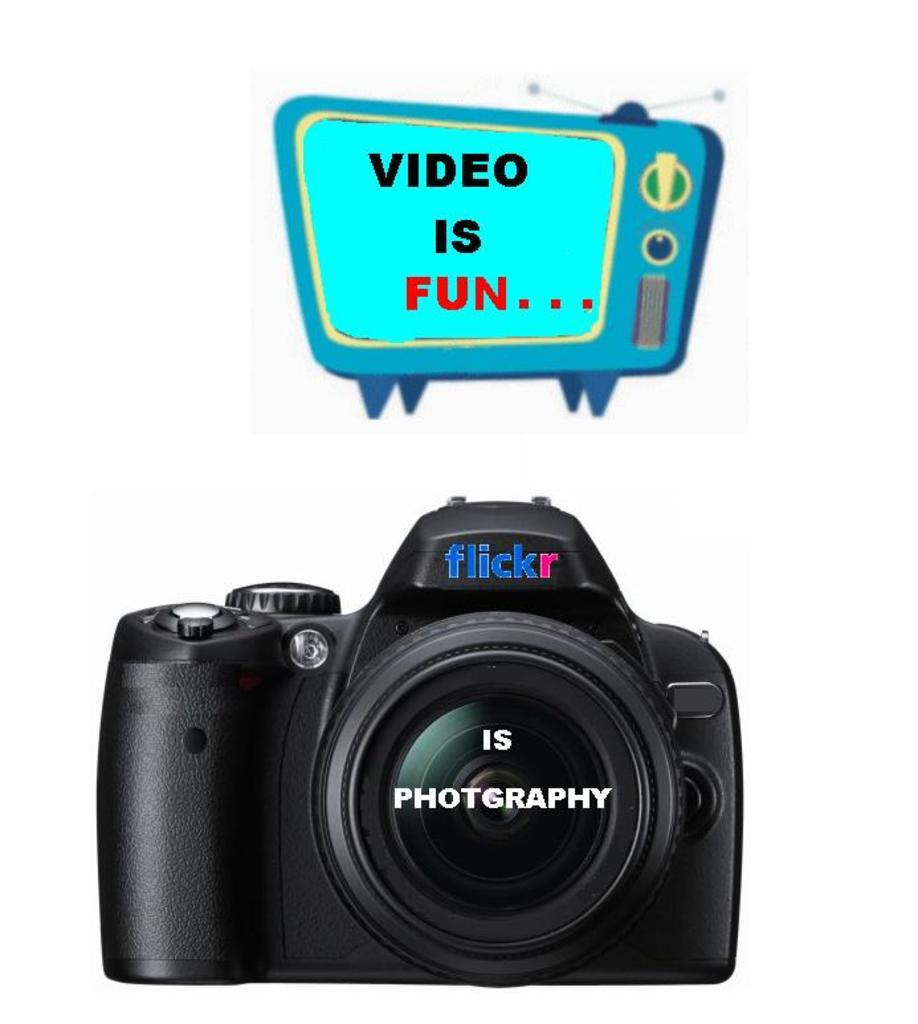What type of device is shown in the image? There is a digital camera in the image. What other electronic device is depicted in the image? There is a depiction of a TV in the image. Are there any words or letters visible in the image? Yes, there is text visible in the image. Can you see any salt being used in the image? There is no salt present in the image. Is there a boat visible in the image? There is no boat present in the image. 